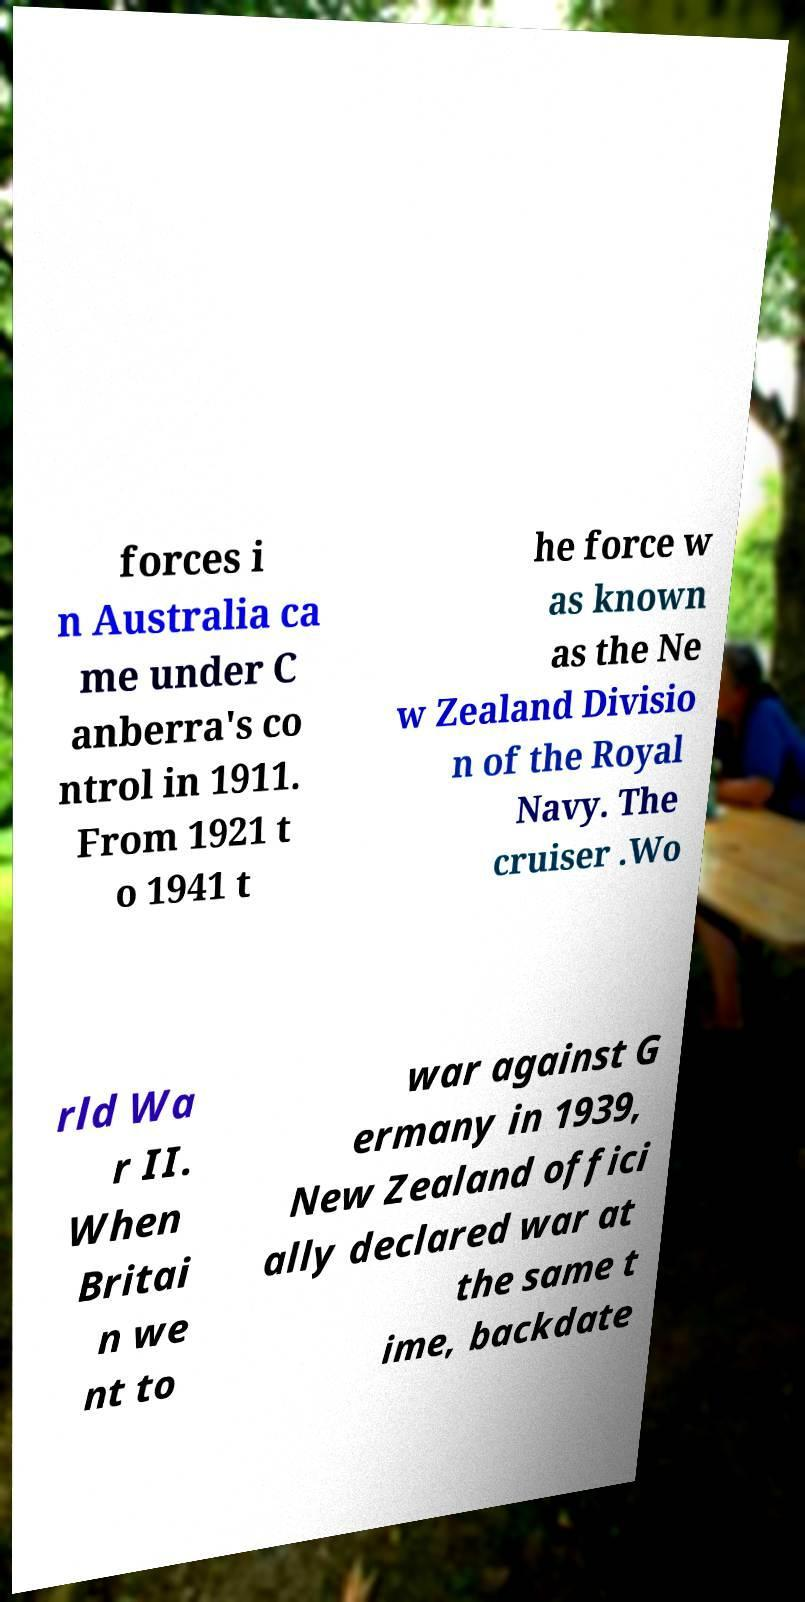Can you accurately transcribe the text from the provided image for me? forces i n Australia ca me under C anberra's co ntrol in 1911. From 1921 t o 1941 t he force w as known as the Ne w Zealand Divisio n of the Royal Navy. The cruiser .Wo rld Wa r II. When Britai n we nt to war against G ermany in 1939, New Zealand offici ally declared war at the same t ime, backdate 